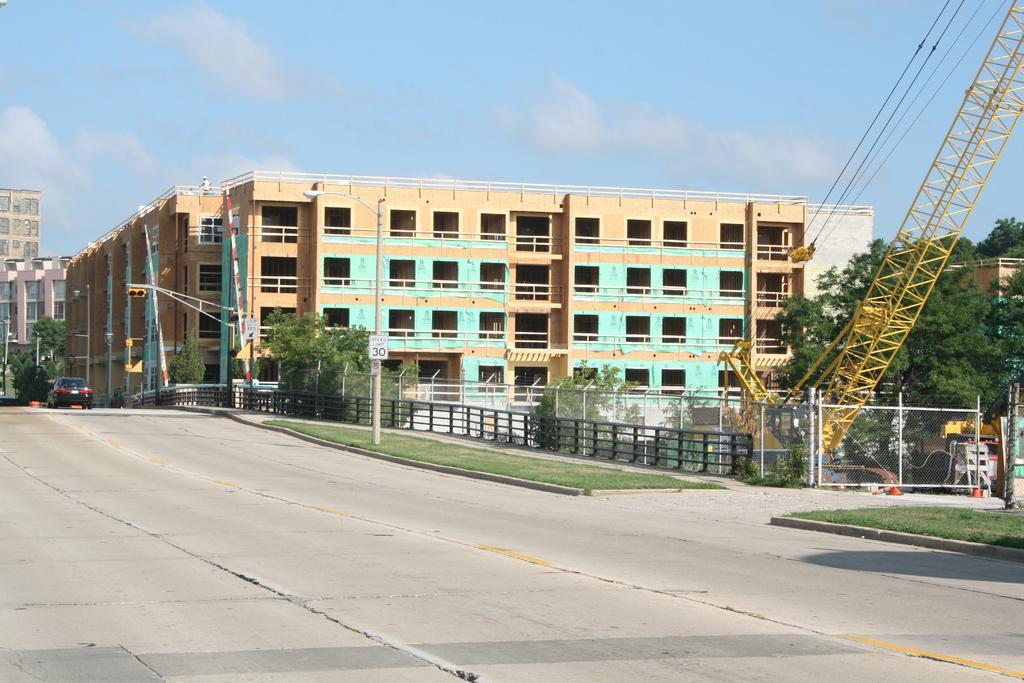Describe this image in one or two sentences. In this picture we can see a vehicle on the road an on the right side of the vehicle there is a fence, trees a pole with traffic signals, crane and buildings. Behind the buildings there is a sky. 